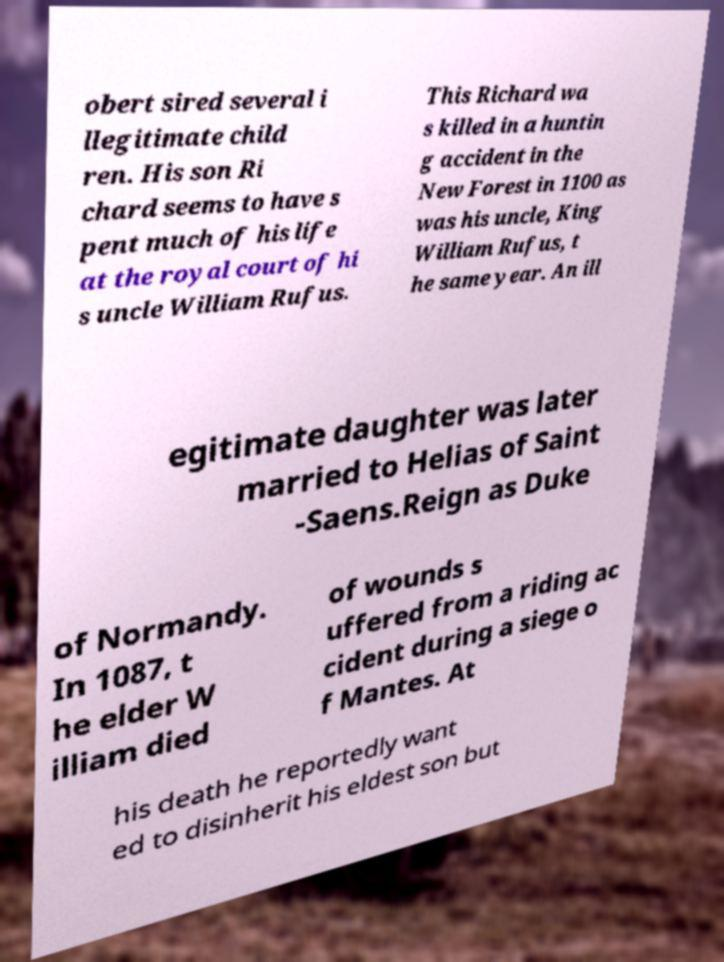There's text embedded in this image that I need extracted. Can you transcribe it verbatim? obert sired several i llegitimate child ren. His son Ri chard seems to have s pent much of his life at the royal court of hi s uncle William Rufus. This Richard wa s killed in a huntin g accident in the New Forest in 1100 as was his uncle, King William Rufus, t he same year. An ill egitimate daughter was later married to Helias of Saint -Saens.Reign as Duke of Normandy. In 1087, t he elder W illiam died of wounds s uffered from a riding ac cident during a siege o f Mantes. At his death he reportedly want ed to disinherit his eldest son but 